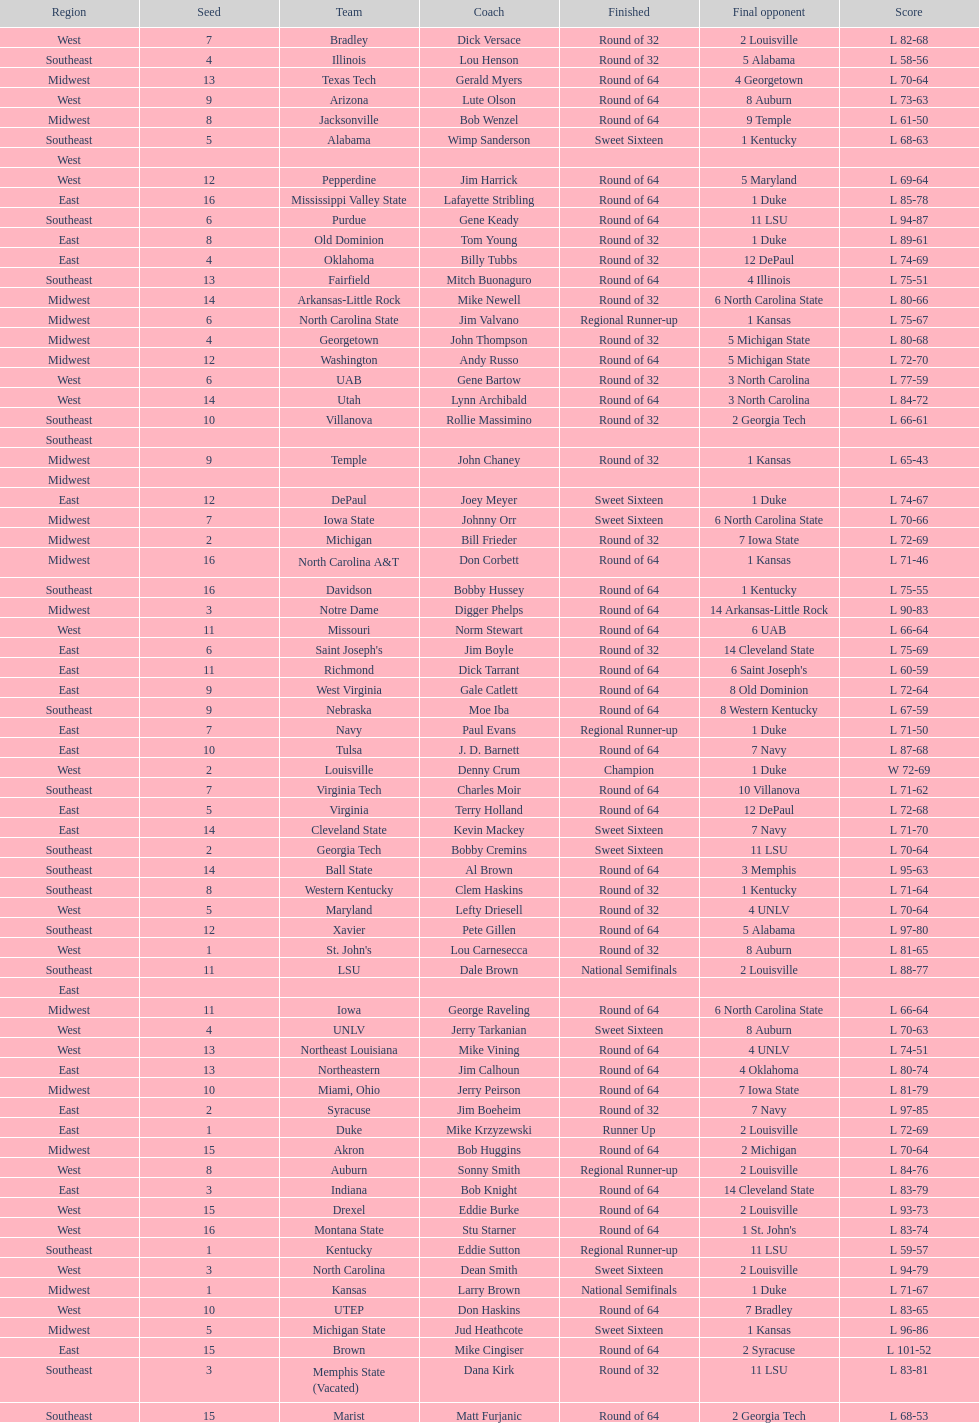Would you be able to parse every entry in this table? {'header': ['Region', 'Seed', 'Team', 'Coach', 'Finished', 'Final opponent', 'Score'], 'rows': [['West', '7', 'Bradley', 'Dick Versace', 'Round of 32', '2 Louisville', 'L 82-68'], ['Southeast', '4', 'Illinois', 'Lou Henson', 'Round of 32', '5 Alabama', 'L 58-56'], ['Midwest', '13', 'Texas Tech', 'Gerald Myers', 'Round of 64', '4 Georgetown', 'L 70-64'], ['West', '9', 'Arizona', 'Lute Olson', 'Round of 64', '8 Auburn', 'L 73-63'], ['Midwest', '8', 'Jacksonville', 'Bob Wenzel', 'Round of 64', '9 Temple', 'L 61-50'], ['Southeast', '5', 'Alabama', 'Wimp Sanderson', 'Sweet Sixteen', '1 Kentucky', 'L 68-63'], ['West', '', '', '', '', '', ''], ['West', '12', 'Pepperdine', 'Jim Harrick', 'Round of 64', '5 Maryland', 'L 69-64'], ['East', '16', 'Mississippi Valley State', 'Lafayette Stribling', 'Round of 64', '1 Duke', 'L 85-78'], ['Southeast', '6', 'Purdue', 'Gene Keady', 'Round of 64', '11 LSU', 'L 94-87'], ['East', '8', 'Old Dominion', 'Tom Young', 'Round of 32', '1 Duke', 'L 89-61'], ['East', '4', 'Oklahoma', 'Billy Tubbs', 'Round of 32', '12 DePaul', 'L 74-69'], ['Southeast', '13', 'Fairfield', 'Mitch Buonaguro', 'Round of 64', '4 Illinois', 'L 75-51'], ['Midwest', '14', 'Arkansas-Little Rock', 'Mike Newell', 'Round of 32', '6 North Carolina State', 'L 80-66'], ['Midwest', '6', 'North Carolina State', 'Jim Valvano', 'Regional Runner-up', '1 Kansas', 'L 75-67'], ['Midwest', '4', 'Georgetown', 'John Thompson', 'Round of 32', '5 Michigan State', 'L 80-68'], ['Midwest', '12', 'Washington', 'Andy Russo', 'Round of 64', '5 Michigan State', 'L 72-70'], ['West', '6', 'UAB', 'Gene Bartow', 'Round of 32', '3 North Carolina', 'L 77-59'], ['West', '14', 'Utah', 'Lynn Archibald', 'Round of 64', '3 North Carolina', 'L 84-72'], ['Southeast', '10', 'Villanova', 'Rollie Massimino', 'Round of 32', '2 Georgia Tech', 'L 66-61'], ['Southeast', '', '', '', '', '', ''], ['Midwest', '9', 'Temple', 'John Chaney', 'Round of 32', '1 Kansas', 'L 65-43'], ['Midwest', '', '', '', '', '', ''], ['East', '12', 'DePaul', 'Joey Meyer', 'Sweet Sixteen', '1 Duke', 'L 74-67'], ['Midwest', '7', 'Iowa State', 'Johnny Orr', 'Sweet Sixteen', '6 North Carolina State', 'L 70-66'], ['Midwest', '2', 'Michigan', 'Bill Frieder', 'Round of 32', '7 Iowa State', 'L 72-69'], ['Midwest', '16', 'North Carolina A&T', 'Don Corbett', 'Round of 64', '1 Kansas', 'L 71-46'], ['Southeast', '16', 'Davidson', 'Bobby Hussey', 'Round of 64', '1 Kentucky', 'L 75-55'], ['Midwest', '3', 'Notre Dame', 'Digger Phelps', 'Round of 64', '14 Arkansas-Little Rock', 'L 90-83'], ['West', '11', 'Missouri', 'Norm Stewart', 'Round of 64', '6 UAB', 'L 66-64'], ['East', '6', "Saint Joseph's", 'Jim Boyle', 'Round of 32', '14 Cleveland State', 'L 75-69'], ['East', '11', 'Richmond', 'Dick Tarrant', 'Round of 64', "6 Saint Joseph's", 'L 60-59'], ['East', '9', 'West Virginia', 'Gale Catlett', 'Round of 64', '8 Old Dominion', 'L 72-64'], ['Southeast', '9', 'Nebraska', 'Moe Iba', 'Round of 64', '8 Western Kentucky', 'L 67-59'], ['East', '7', 'Navy', 'Paul Evans', 'Regional Runner-up', '1 Duke', 'L 71-50'], ['East', '10', 'Tulsa', 'J. D. Barnett', 'Round of 64', '7 Navy', 'L 87-68'], ['West', '2', 'Louisville', 'Denny Crum', 'Champion', '1 Duke', 'W 72-69'], ['Southeast', '7', 'Virginia Tech', 'Charles Moir', 'Round of 64', '10 Villanova', 'L 71-62'], ['East', '5', 'Virginia', 'Terry Holland', 'Round of 64', '12 DePaul', 'L 72-68'], ['East', '14', 'Cleveland State', 'Kevin Mackey', 'Sweet Sixteen', '7 Navy', 'L 71-70'], ['Southeast', '2', 'Georgia Tech', 'Bobby Cremins', 'Sweet Sixteen', '11 LSU', 'L 70-64'], ['Southeast', '14', 'Ball State', 'Al Brown', 'Round of 64', '3 Memphis', 'L 95-63'], ['Southeast', '8', 'Western Kentucky', 'Clem Haskins', 'Round of 32', '1 Kentucky', 'L 71-64'], ['West', '5', 'Maryland', 'Lefty Driesell', 'Round of 32', '4 UNLV', 'L 70-64'], ['Southeast', '12', 'Xavier', 'Pete Gillen', 'Round of 64', '5 Alabama', 'L 97-80'], ['West', '1', "St. John's", 'Lou Carnesecca', 'Round of 32', '8 Auburn', 'L 81-65'], ['Southeast', '11', 'LSU', 'Dale Brown', 'National Semifinals', '2 Louisville', 'L 88-77'], ['East', '', '', '', '', '', ''], ['Midwest', '11', 'Iowa', 'George Raveling', 'Round of 64', '6 North Carolina State', 'L 66-64'], ['West', '4', 'UNLV', 'Jerry Tarkanian', 'Sweet Sixteen', '8 Auburn', 'L 70-63'], ['West', '13', 'Northeast Louisiana', 'Mike Vining', 'Round of 64', '4 UNLV', 'L 74-51'], ['East', '13', 'Northeastern', 'Jim Calhoun', 'Round of 64', '4 Oklahoma', 'L 80-74'], ['Midwest', '10', 'Miami, Ohio', 'Jerry Peirson', 'Round of 64', '7 Iowa State', 'L 81-79'], ['East', '2', 'Syracuse', 'Jim Boeheim', 'Round of 32', '7 Navy', 'L 97-85'], ['East', '1', 'Duke', 'Mike Krzyzewski', 'Runner Up', '2 Louisville', 'L 72-69'], ['Midwest', '15', 'Akron', 'Bob Huggins', 'Round of 64', '2 Michigan', 'L 70-64'], ['West', '8', 'Auburn', 'Sonny Smith', 'Regional Runner-up', '2 Louisville', 'L 84-76'], ['East', '3', 'Indiana', 'Bob Knight', 'Round of 64', '14 Cleveland State', 'L 83-79'], ['West', '15', 'Drexel', 'Eddie Burke', 'Round of 64', '2 Louisville', 'L 93-73'], ['West', '16', 'Montana State', 'Stu Starner', 'Round of 64', "1 St. John's", 'L 83-74'], ['Southeast', '1', 'Kentucky', 'Eddie Sutton', 'Regional Runner-up', '11 LSU', 'L 59-57'], ['West', '3', 'North Carolina', 'Dean Smith', 'Sweet Sixteen', '2 Louisville', 'L 94-79'], ['Midwest', '1', 'Kansas', 'Larry Brown', 'National Semifinals', '1 Duke', 'L 71-67'], ['West', '10', 'UTEP', 'Don Haskins', 'Round of 64', '7 Bradley', 'L 83-65'], ['Midwest', '5', 'Michigan State', 'Jud Heathcote', 'Sweet Sixteen', '1 Kansas', 'L 96-86'], ['East', '15', 'Brown', 'Mike Cingiser', 'Round of 64', '2 Syracuse', 'L 101-52'], ['Southeast', '3', 'Memphis State (Vacated)', 'Dana Kirk', 'Round of 32', '11 LSU', 'L 83-81'], ['Southeast', '15', 'Marist', 'Matt Furjanic', 'Round of 64', '2 Georgia Tech', 'L 68-53']]} How many teams are in the east region. 16. 